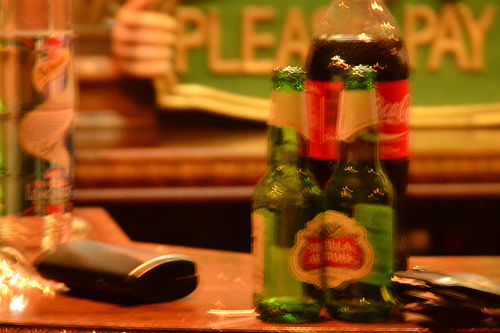<image>
Can you confirm if the beer bottle is in front of the coke? Yes. The beer bottle is positioned in front of the coke, appearing closer to the camera viewpoint. 